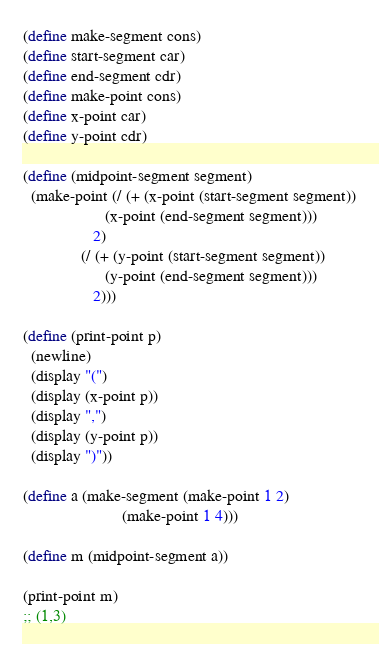<code> <loc_0><loc_0><loc_500><loc_500><_Scheme_>(define make-segment cons)
(define start-segment car)
(define end-segment cdr)
(define make-point cons)
(define x-point car)
(define y-point cdr)

(define (midpoint-segment segment)
  (make-point (/ (+ (x-point (start-segment segment))
                    (x-point (end-segment segment)))
                 2)
              (/ (+ (y-point (start-segment segment))
                    (y-point (end-segment segment)))
                 2)))

(define (print-point p)
  (newline)
  (display "(")
  (display (x-point p))
  (display ",")
  (display (y-point p))
  (display ")"))

(define a (make-segment (make-point 1 2)
                        (make-point 1 4)))

(define m (midpoint-segment a))

(print-point m)
;; (1,3)
</code> 